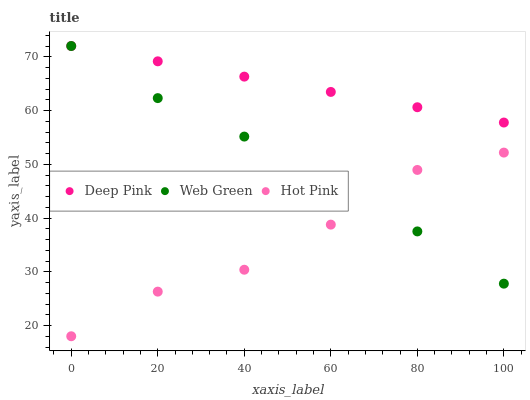Does Hot Pink have the minimum area under the curve?
Answer yes or no. Yes. Does Deep Pink have the maximum area under the curve?
Answer yes or no. Yes. Does Web Green have the minimum area under the curve?
Answer yes or no. No. Does Web Green have the maximum area under the curve?
Answer yes or no. No. Is Deep Pink the smoothest?
Answer yes or no. Yes. Is Hot Pink the roughest?
Answer yes or no. Yes. Is Web Green the smoothest?
Answer yes or no. No. Is Web Green the roughest?
Answer yes or no. No. Does Hot Pink have the lowest value?
Answer yes or no. Yes. Does Web Green have the lowest value?
Answer yes or no. No. Does Web Green have the highest value?
Answer yes or no. Yes. Does Hot Pink have the highest value?
Answer yes or no. No. Is Hot Pink less than Deep Pink?
Answer yes or no. Yes. Is Deep Pink greater than Hot Pink?
Answer yes or no. Yes. Does Hot Pink intersect Web Green?
Answer yes or no. Yes. Is Hot Pink less than Web Green?
Answer yes or no. No. Is Hot Pink greater than Web Green?
Answer yes or no. No. Does Hot Pink intersect Deep Pink?
Answer yes or no. No. 